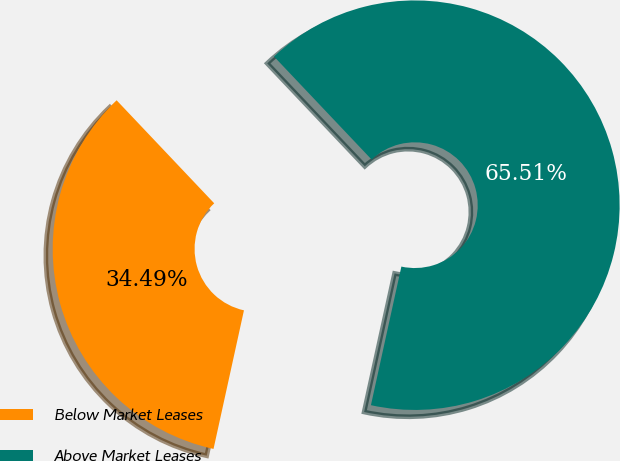Convert chart to OTSL. <chart><loc_0><loc_0><loc_500><loc_500><pie_chart><fcel>Below Market Leases<fcel>Above Market Leases<nl><fcel>34.49%<fcel>65.51%<nl></chart> 